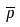<formula> <loc_0><loc_0><loc_500><loc_500>\overline { p }</formula> 